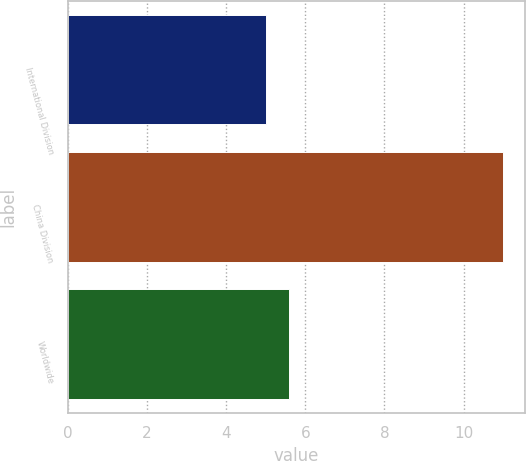Convert chart to OTSL. <chart><loc_0><loc_0><loc_500><loc_500><bar_chart><fcel>International Division<fcel>China Division<fcel>Worldwide<nl><fcel>5<fcel>11<fcel>5.6<nl></chart> 